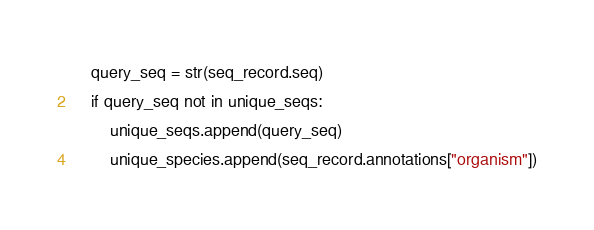Convert code to text. <code><loc_0><loc_0><loc_500><loc_500><_Python_>    query_seq = str(seq_record.seq)
    if query_seq not in unique_seqs:
        unique_seqs.append(query_seq)
        unique_species.append(seq_record.annotations["organism"])</code> 